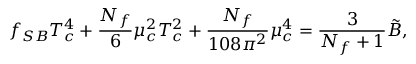<formula> <loc_0><loc_0><loc_500><loc_500>f _ { S B } T _ { c } ^ { 4 } + { \frac { N _ { f } } { 6 } } \mu _ { c } ^ { 2 } T _ { c } ^ { 2 } + { \frac { N _ { f } } { 1 0 8 \pi ^ { 2 } } } \mu _ { c } ^ { 4 } = { \frac { 3 } { N _ { f } + 1 } } \tilde { B } ,</formula> 